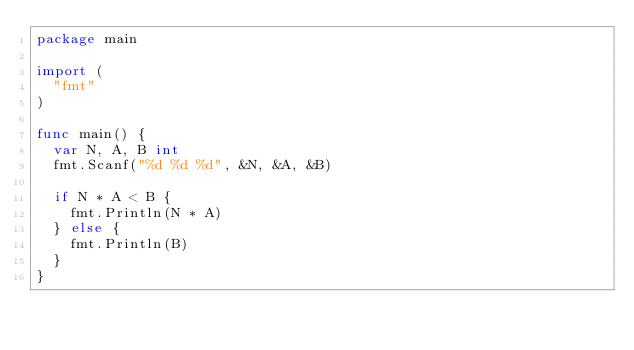<code> <loc_0><loc_0><loc_500><loc_500><_Go_>package main

import (
  "fmt"
)

func main() {
  var N, A, B int
  fmt.Scanf("%d %d %d", &N, &A, &B)

  if N * A < B {
    fmt.Println(N * A)
  } else {
    fmt.Println(B)
  }
}
</code> 